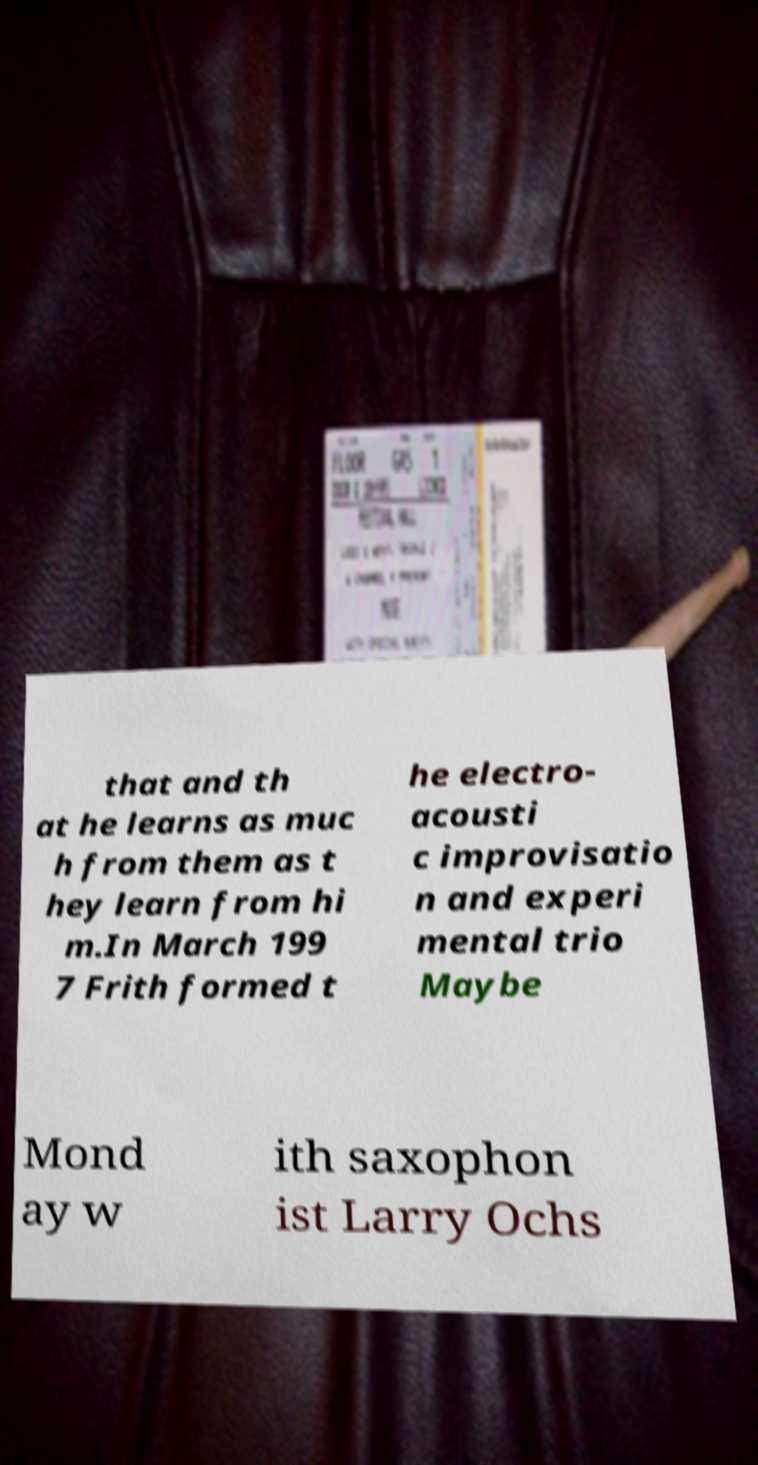Could you extract and type out the text from this image? that and th at he learns as muc h from them as t hey learn from hi m.In March 199 7 Frith formed t he electro- acousti c improvisatio n and experi mental trio Maybe Mond ay w ith saxophon ist Larry Ochs 